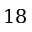Convert formula to latex. <formula><loc_0><loc_0><loc_500><loc_500>1 8</formula> 